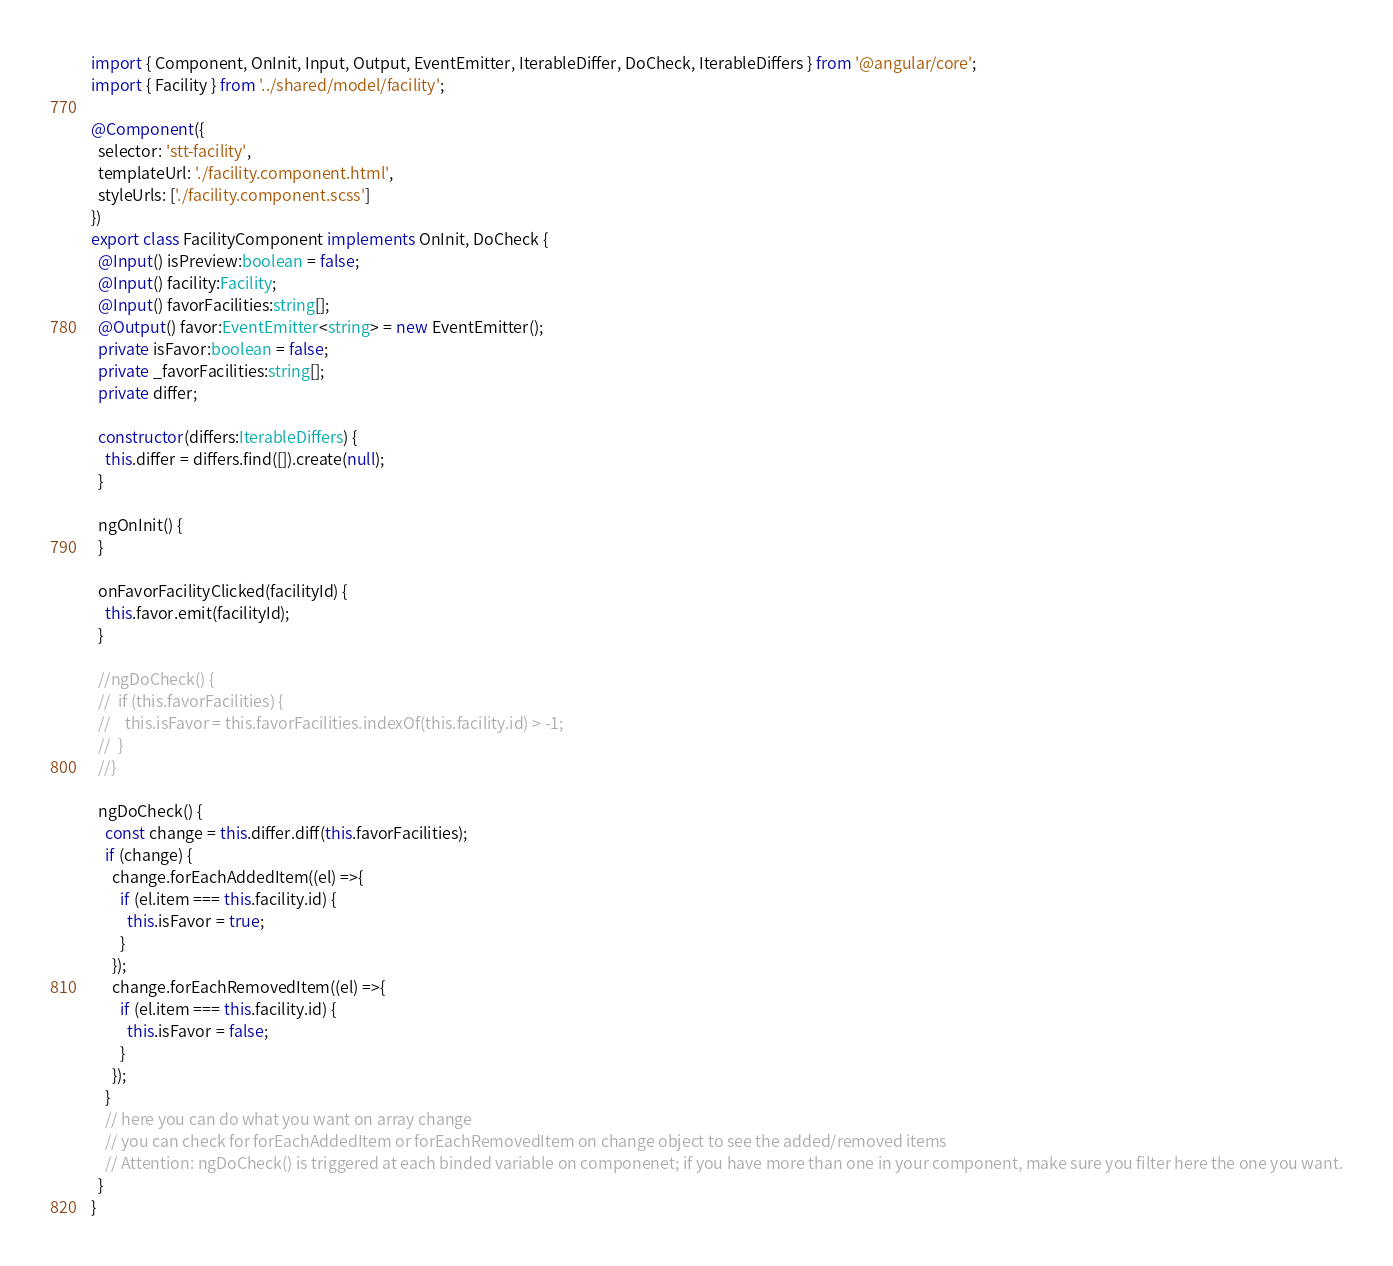Convert code to text. <code><loc_0><loc_0><loc_500><loc_500><_TypeScript_>import { Component, OnInit, Input, Output, EventEmitter, IterableDiffer, DoCheck, IterableDiffers } from '@angular/core';
import { Facility } from '../shared/model/facility';

@Component({
  selector: 'stt-facility',
  templateUrl: './facility.component.html',
  styleUrls: ['./facility.component.scss']
})
export class FacilityComponent implements OnInit, DoCheck {
  @Input() isPreview:boolean = false;
  @Input() facility:Facility;
  @Input() favorFacilities:string[];
  @Output() favor:EventEmitter<string> = new EventEmitter();
  private isFavor:boolean = false;
  private _favorFacilities:string[];
  private differ;

  constructor(differs:IterableDiffers) {
    this.differ = differs.find([]).create(null);
  }

  ngOnInit() {
  }

  onFavorFacilityClicked(facilityId) {
    this.favor.emit(facilityId);
  }

  //ngDoCheck() {
  //  if (this.favorFacilities) {
  //    this.isFavor = this.favorFacilities.indexOf(this.facility.id) > -1;
  //  }
  //}

  ngDoCheck() {
    const change = this.differ.diff(this.favorFacilities);
    if (change) {
      change.forEachAddedItem((el) =>{
        if (el.item === this.facility.id) {
          this.isFavor = true;
        }
      });
      change.forEachRemovedItem((el) =>{
        if (el.item === this.facility.id) {
          this.isFavor = false;
        }
      });
    }
    // here you can do what you want on array change
    // you can check for forEachAddedItem or forEachRemovedItem on change object to see the added/removed items
    // Attention: ngDoCheck() is triggered at each binded variable on componenet; if you have more than one in your component, make sure you filter here the one you want.
  }
}
</code> 